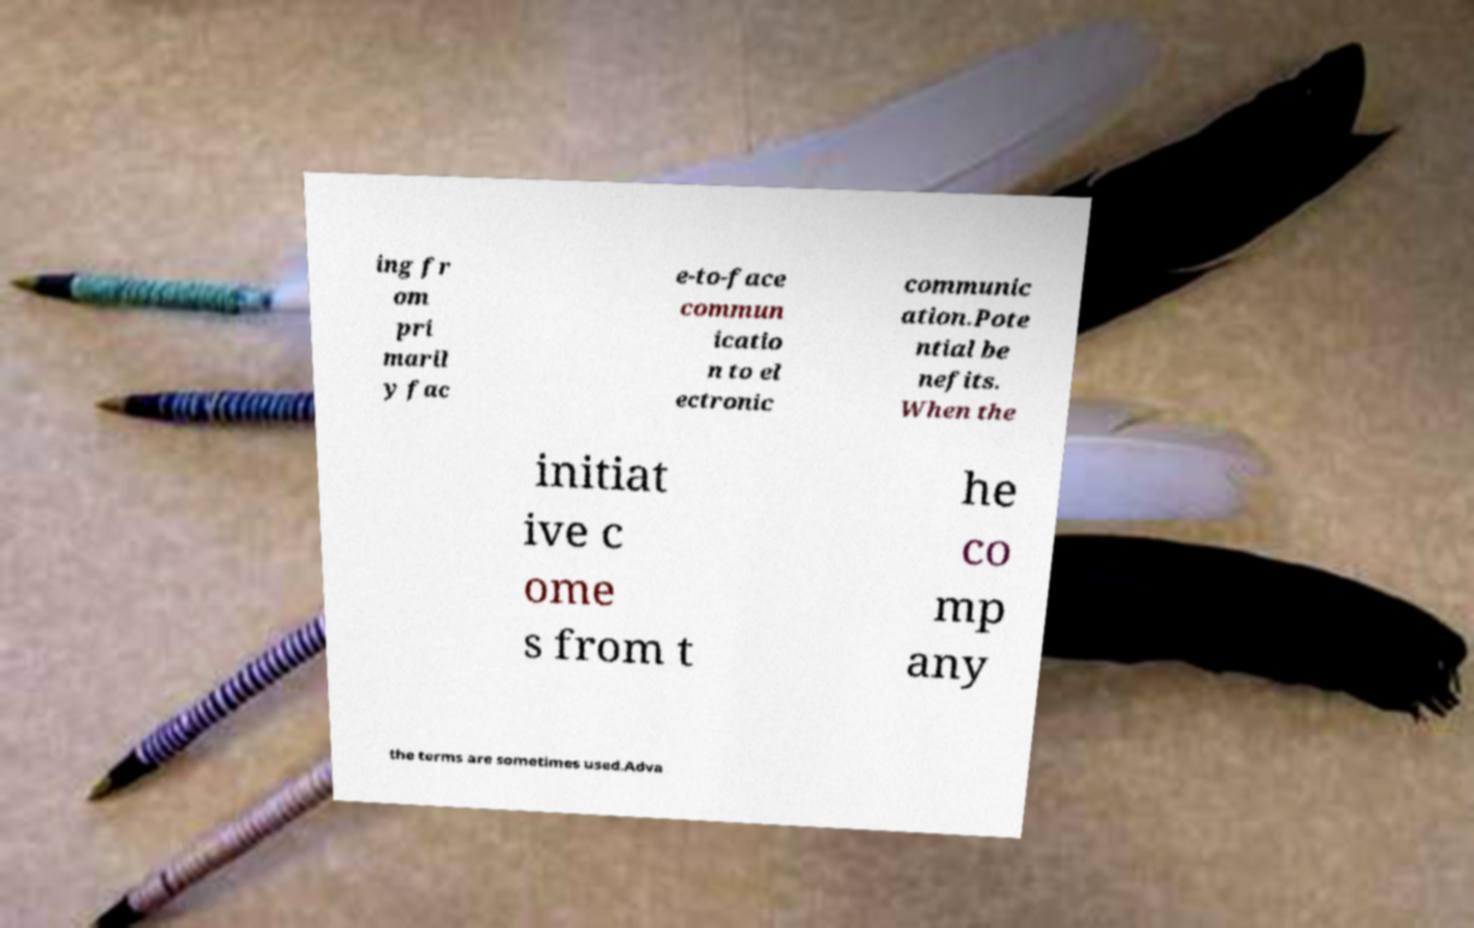Could you assist in decoding the text presented in this image and type it out clearly? ing fr om pri maril y fac e-to-face commun icatio n to el ectronic communic ation.Pote ntial be nefits. When the initiat ive c ome s from t he co mp any the terms are sometimes used.Adva 